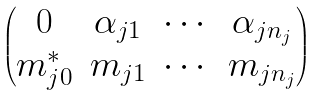<formula> <loc_0><loc_0><loc_500><loc_500>\begin{pmatrix} 0 & \alpha _ { j 1 } & \cdots & \alpha _ { j n _ { j } } \\ m _ { j 0 } ^ { * } & m _ { j 1 } & \cdots & m _ { j n _ { j } } \end{pmatrix}</formula> 